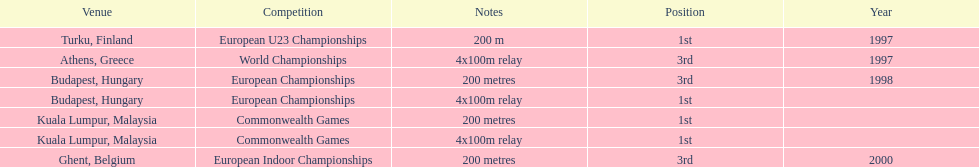How many total years did golding compete? 3. 